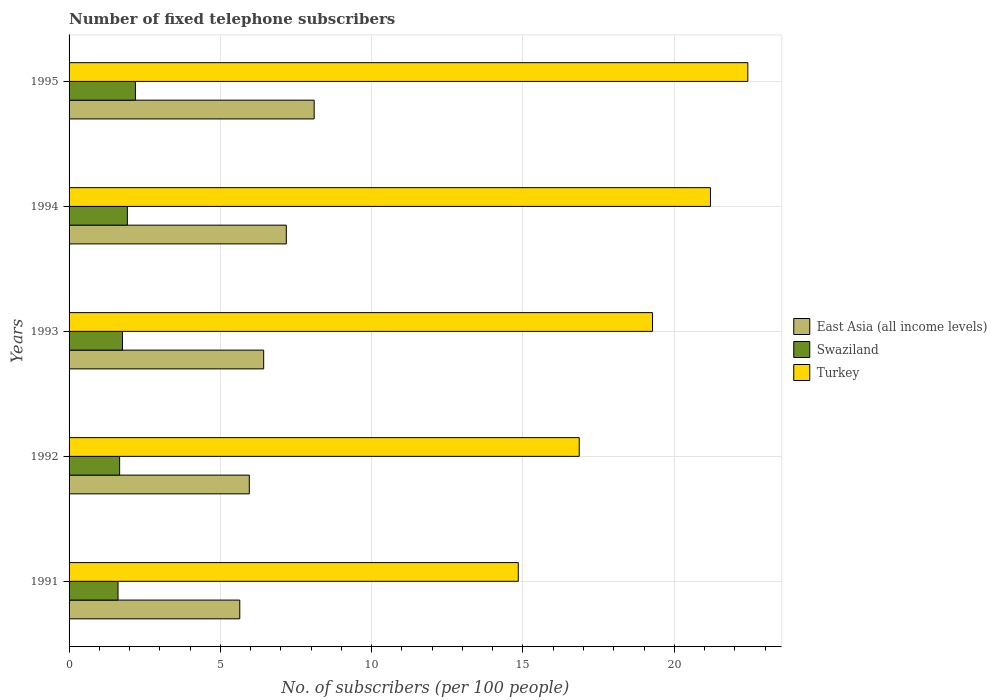What is the label of the 2nd group of bars from the top?
Provide a succinct answer. 1994. In how many cases, is the number of bars for a given year not equal to the number of legend labels?
Your answer should be very brief. 0. What is the number of fixed telephone subscribers in Turkey in 1991?
Your answer should be compact. 14.85. Across all years, what is the maximum number of fixed telephone subscribers in East Asia (all income levels)?
Offer a terse response. 8.1. Across all years, what is the minimum number of fixed telephone subscribers in East Asia (all income levels)?
Your response must be concise. 5.64. In which year was the number of fixed telephone subscribers in Swaziland minimum?
Give a very brief answer. 1991. What is the total number of fixed telephone subscribers in Swaziland in the graph?
Ensure brevity in your answer.  9.17. What is the difference between the number of fixed telephone subscribers in Swaziland in 1992 and that in 1995?
Provide a succinct answer. -0.52. What is the difference between the number of fixed telephone subscribers in East Asia (all income levels) in 1991 and the number of fixed telephone subscribers in Turkey in 1995?
Your answer should be very brief. -16.79. What is the average number of fixed telephone subscribers in Swaziland per year?
Your answer should be compact. 1.83. In the year 1995, what is the difference between the number of fixed telephone subscribers in Swaziland and number of fixed telephone subscribers in East Asia (all income levels)?
Keep it short and to the point. -5.91. In how many years, is the number of fixed telephone subscribers in Turkey greater than 15 ?
Ensure brevity in your answer.  4. What is the ratio of the number of fixed telephone subscribers in East Asia (all income levels) in 1991 to that in 1993?
Your response must be concise. 0.88. Is the number of fixed telephone subscribers in East Asia (all income levels) in 1992 less than that in 1993?
Your answer should be compact. Yes. Is the difference between the number of fixed telephone subscribers in Swaziland in 1992 and 1994 greater than the difference between the number of fixed telephone subscribers in East Asia (all income levels) in 1992 and 1994?
Keep it short and to the point. Yes. What is the difference between the highest and the second highest number of fixed telephone subscribers in Swaziland?
Your response must be concise. 0.27. What is the difference between the highest and the lowest number of fixed telephone subscribers in Swaziland?
Offer a terse response. 0.58. What does the 2nd bar from the top in 1993 represents?
Ensure brevity in your answer.  Swaziland. Are all the bars in the graph horizontal?
Ensure brevity in your answer.  Yes. How many years are there in the graph?
Offer a terse response. 5. What is the difference between two consecutive major ticks on the X-axis?
Ensure brevity in your answer.  5. Does the graph contain any zero values?
Your answer should be very brief. No. Does the graph contain grids?
Your response must be concise. Yes. Where does the legend appear in the graph?
Make the answer very short. Center right. How many legend labels are there?
Provide a short and direct response. 3. How are the legend labels stacked?
Make the answer very short. Vertical. What is the title of the graph?
Ensure brevity in your answer.  Number of fixed telephone subscribers. What is the label or title of the X-axis?
Keep it short and to the point. No. of subscribers (per 100 people). What is the No. of subscribers (per 100 people) in East Asia (all income levels) in 1991?
Make the answer very short. 5.64. What is the No. of subscribers (per 100 people) in Swaziland in 1991?
Your answer should be very brief. 1.62. What is the No. of subscribers (per 100 people) in Turkey in 1991?
Keep it short and to the point. 14.85. What is the No. of subscribers (per 100 people) of East Asia (all income levels) in 1992?
Offer a very short reply. 5.96. What is the No. of subscribers (per 100 people) in Swaziland in 1992?
Offer a terse response. 1.67. What is the No. of subscribers (per 100 people) of Turkey in 1992?
Your response must be concise. 16.86. What is the No. of subscribers (per 100 people) of East Asia (all income levels) in 1993?
Your answer should be compact. 6.43. What is the No. of subscribers (per 100 people) in Swaziland in 1993?
Offer a terse response. 1.76. What is the No. of subscribers (per 100 people) of Turkey in 1993?
Your response must be concise. 19.28. What is the No. of subscribers (per 100 people) in East Asia (all income levels) in 1994?
Your answer should be compact. 7.18. What is the No. of subscribers (per 100 people) of Swaziland in 1994?
Offer a very short reply. 1.93. What is the No. of subscribers (per 100 people) of Turkey in 1994?
Your response must be concise. 21.2. What is the No. of subscribers (per 100 people) of East Asia (all income levels) in 1995?
Offer a terse response. 8.1. What is the No. of subscribers (per 100 people) in Swaziland in 1995?
Your answer should be very brief. 2.19. What is the No. of subscribers (per 100 people) in Turkey in 1995?
Your answer should be compact. 22.43. Across all years, what is the maximum No. of subscribers (per 100 people) in East Asia (all income levels)?
Provide a short and direct response. 8.1. Across all years, what is the maximum No. of subscribers (per 100 people) in Swaziland?
Offer a very short reply. 2.19. Across all years, what is the maximum No. of subscribers (per 100 people) in Turkey?
Provide a short and direct response. 22.43. Across all years, what is the minimum No. of subscribers (per 100 people) of East Asia (all income levels)?
Offer a very short reply. 5.64. Across all years, what is the minimum No. of subscribers (per 100 people) in Swaziland?
Give a very brief answer. 1.62. Across all years, what is the minimum No. of subscribers (per 100 people) in Turkey?
Your response must be concise. 14.85. What is the total No. of subscribers (per 100 people) of East Asia (all income levels) in the graph?
Ensure brevity in your answer.  33.31. What is the total No. of subscribers (per 100 people) of Swaziland in the graph?
Provide a succinct answer. 9.17. What is the total No. of subscribers (per 100 people) in Turkey in the graph?
Offer a terse response. 94.61. What is the difference between the No. of subscribers (per 100 people) in East Asia (all income levels) in 1991 and that in 1992?
Your answer should be compact. -0.31. What is the difference between the No. of subscribers (per 100 people) of Swaziland in 1991 and that in 1992?
Provide a succinct answer. -0.05. What is the difference between the No. of subscribers (per 100 people) of Turkey in 1991 and that in 1992?
Your answer should be very brief. -2.01. What is the difference between the No. of subscribers (per 100 people) of East Asia (all income levels) in 1991 and that in 1993?
Ensure brevity in your answer.  -0.79. What is the difference between the No. of subscribers (per 100 people) in Swaziland in 1991 and that in 1993?
Keep it short and to the point. -0.15. What is the difference between the No. of subscribers (per 100 people) in Turkey in 1991 and that in 1993?
Your response must be concise. -4.44. What is the difference between the No. of subscribers (per 100 people) in East Asia (all income levels) in 1991 and that in 1994?
Your answer should be compact. -1.54. What is the difference between the No. of subscribers (per 100 people) in Swaziland in 1991 and that in 1994?
Ensure brevity in your answer.  -0.31. What is the difference between the No. of subscribers (per 100 people) in Turkey in 1991 and that in 1994?
Give a very brief answer. -6.35. What is the difference between the No. of subscribers (per 100 people) of East Asia (all income levels) in 1991 and that in 1995?
Offer a terse response. -2.46. What is the difference between the No. of subscribers (per 100 people) of Swaziland in 1991 and that in 1995?
Your answer should be compact. -0.58. What is the difference between the No. of subscribers (per 100 people) of Turkey in 1991 and that in 1995?
Offer a terse response. -7.59. What is the difference between the No. of subscribers (per 100 people) in East Asia (all income levels) in 1992 and that in 1993?
Keep it short and to the point. -0.47. What is the difference between the No. of subscribers (per 100 people) of Swaziland in 1992 and that in 1993?
Your response must be concise. -0.09. What is the difference between the No. of subscribers (per 100 people) in Turkey in 1992 and that in 1993?
Keep it short and to the point. -2.42. What is the difference between the No. of subscribers (per 100 people) in East Asia (all income levels) in 1992 and that in 1994?
Provide a succinct answer. -1.22. What is the difference between the No. of subscribers (per 100 people) in Swaziland in 1992 and that in 1994?
Offer a very short reply. -0.26. What is the difference between the No. of subscribers (per 100 people) in Turkey in 1992 and that in 1994?
Offer a terse response. -4.34. What is the difference between the No. of subscribers (per 100 people) of East Asia (all income levels) in 1992 and that in 1995?
Keep it short and to the point. -2.14. What is the difference between the No. of subscribers (per 100 people) of Swaziland in 1992 and that in 1995?
Give a very brief answer. -0.52. What is the difference between the No. of subscribers (per 100 people) in Turkey in 1992 and that in 1995?
Ensure brevity in your answer.  -5.57. What is the difference between the No. of subscribers (per 100 people) of East Asia (all income levels) in 1993 and that in 1994?
Ensure brevity in your answer.  -0.75. What is the difference between the No. of subscribers (per 100 people) of Swaziland in 1993 and that in 1994?
Keep it short and to the point. -0.16. What is the difference between the No. of subscribers (per 100 people) of Turkey in 1993 and that in 1994?
Provide a short and direct response. -1.91. What is the difference between the No. of subscribers (per 100 people) in East Asia (all income levels) in 1993 and that in 1995?
Provide a succinct answer. -1.67. What is the difference between the No. of subscribers (per 100 people) in Swaziland in 1993 and that in 1995?
Offer a very short reply. -0.43. What is the difference between the No. of subscribers (per 100 people) in Turkey in 1993 and that in 1995?
Keep it short and to the point. -3.15. What is the difference between the No. of subscribers (per 100 people) of East Asia (all income levels) in 1994 and that in 1995?
Offer a terse response. -0.92. What is the difference between the No. of subscribers (per 100 people) in Swaziland in 1994 and that in 1995?
Your answer should be compact. -0.27. What is the difference between the No. of subscribers (per 100 people) of Turkey in 1994 and that in 1995?
Your response must be concise. -1.23. What is the difference between the No. of subscribers (per 100 people) in East Asia (all income levels) in 1991 and the No. of subscribers (per 100 people) in Swaziland in 1992?
Give a very brief answer. 3.97. What is the difference between the No. of subscribers (per 100 people) in East Asia (all income levels) in 1991 and the No. of subscribers (per 100 people) in Turkey in 1992?
Provide a short and direct response. -11.22. What is the difference between the No. of subscribers (per 100 people) in Swaziland in 1991 and the No. of subscribers (per 100 people) in Turkey in 1992?
Your answer should be very brief. -15.24. What is the difference between the No. of subscribers (per 100 people) in East Asia (all income levels) in 1991 and the No. of subscribers (per 100 people) in Swaziland in 1993?
Ensure brevity in your answer.  3.88. What is the difference between the No. of subscribers (per 100 people) of East Asia (all income levels) in 1991 and the No. of subscribers (per 100 people) of Turkey in 1993?
Give a very brief answer. -13.64. What is the difference between the No. of subscribers (per 100 people) of Swaziland in 1991 and the No. of subscribers (per 100 people) of Turkey in 1993?
Offer a terse response. -17.66. What is the difference between the No. of subscribers (per 100 people) in East Asia (all income levels) in 1991 and the No. of subscribers (per 100 people) in Swaziland in 1994?
Give a very brief answer. 3.72. What is the difference between the No. of subscribers (per 100 people) of East Asia (all income levels) in 1991 and the No. of subscribers (per 100 people) of Turkey in 1994?
Ensure brevity in your answer.  -15.55. What is the difference between the No. of subscribers (per 100 people) of Swaziland in 1991 and the No. of subscribers (per 100 people) of Turkey in 1994?
Provide a succinct answer. -19.58. What is the difference between the No. of subscribers (per 100 people) of East Asia (all income levels) in 1991 and the No. of subscribers (per 100 people) of Swaziland in 1995?
Make the answer very short. 3.45. What is the difference between the No. of subscribers (per 100 people) of East Asia (all income levels) in 1991 and the No. of subscribers (per 100 people) of Turkey in 1995?
Your answer should be very brief. -16.79. What is the difference between the No. of subscribers (per 100 people) in Swaziland in 1991 and the No. of subscribers (per 100 people) in Turkey in 1995?
Provide a succinct answer. -20.81. What is the difference between the No. of subscribers (per 100 people) of East Asia (all income levels) in 1992 and the No. of subscribers (per 100 people) of Swaziland in 1993?
Provide a succinct answer. 4.19. What is the difference between the No. of subscribers (per 100 people) of East Asia (all income levels) in 1992 and the No. of subscribers (per 100 people) of Turkey in 1993?
Your response must be concise. -13.33. What is the difference between the No. of subscribers (per 100 people) of Swaziland in 1992 and the No. of subscribers (per 100 people) of Turkey in 1993?
Give a very brief answer. -17.61. What is the difference between the No. of subscribers (per 100 people) in East Asia (all income levels) in 1992 and the No. of subscribers (per 100 people) in Swaziland in 1994?
Provide a succinct answer. 4.03. What is the difference between the No. of subscribers (per 100 people) in East Asia (all income levels) in 1992 and the No. of subscribers (per 100 people) in Turkey in 1994?
Your response must be concise. -15.24. What is the difference between the No. of subscribers (per 100 people) of Swaziland in 1992 and the No. of subscribers (per 100 people) of Turkey in 1994?
Ensure brevity in your answer.  -19.53. What is the difference between the No. of subscribers (per 100 people) of East Asia (all income levels) in 1992 and the No. of subscribers (per 100 people) of Swaziland in 1995?
Provide a short and direct response. 3.76. What is the difference between the No. of subscribers (per 100 people) of East Asia (all income levels) in 1992 and the No. of subscribers (per 100 people) of Turkey in 1995?
Offer a terse response. -16.47. What is the difference between the No. of subscribers (per 100 people) in Swaziland in 1992 and the No. of subscribers (per 100 people) in Turkey in 1995?
Keep it short and to the point. -20.76. What is the difference between the No. of subscribers (per 100 people) of East Asia (all income levels) in 1993 and the No. of subscribers (per 100 people) of Swaziland in 1994?
Give a very brief answer. 4.5. What is the difference between the No. of subscribers (per 100 people) of East Asia (all income levels) in 1993 and the No. of subscribers (per 100 people) of Turkey in 1994?
Provide a succinct answer. -14.77. What is the difference between the No. of subscribers (per 100 people) in Swaziland in 1993 and the No. of subscribers (per 100 people) in Turkey in 1994?
Offer a very short reply. -19.43. What is the difference between the No. of subscribers (per 100 people) in East Asia (all income levels) in 1993 and the No. of subscribers (per 100 people) in Swaziland in 1995?
Give a very brief answer. 4.24. What is the difference between the No. of subscribers (per 100 people) of East Asia (all income levels) in 1993 and the No. of subscribers (per 100 people) of Turkey in 1995?
Your response must be concise. -16. What is the difference between the No. of subscribers (per 100 people) of Swaziland in 1993 and the No. of subscribers (per 100 people) of Turkey in 1995?
Provide a short and direct response. -20.67. What is the difference between the No. of subscribers (per 100 people) of East Asia (all income levels) in 1994 and the No. of subscribers (per 100 people) of Swaziland in 1995?
Ensure brevity in your answer.  4.99. What is the difference between the No. of subscribers (per 100 people) of East Asia (all income levels) in 1994 and the No. of subscribers (per 100 people) of Turkey in 1995?
Provide a succinct answer. -15.25. What is the difference between the No. of subscribers (per 100 people) in Swaziland in 1994 and the No. of subscribers (per 100 people) in Turkey in 1995?
Ensure brevity in your answer.  -20.5. What is the average No. of subscribers (per 100 people) in East Asia (all income levels) per year?
Keep it short and to the point. 6.66. What is the average No. of subscribers (per 100 people) of Swaziland per year?
Give a very brief answer. 1.83. What is the average No. of subscribers (per 100 people) in Turkey per year?
Your response must be concise. 18.92. In the year 1991, what is the difference between the No. of subscribers (per 100 people) of East Asia (all income levels) and No. of subscribers (per 100 people) of Swaziland?
Provide a succinct answer. 4.02. In the year 1991, what is the difference between the No. of subscribers (per 100 people) of East Asia (all income levels) and No. of subscribers (per 100 people) of Turkey?
Provide a succinct answer. -9.2. In the year 1991, what is the difference between the No. of subscribers (per 100 people) of Swaziland and No. of subscribers (per 100 people) of Turkey?
Provide a succinct answer. -13.23. In the year 1992, what is the difference between the No. of subscribers (per 100 people) of East Asia (all income levels) and No. of subscribers (per 100 people) of Swaziland?
Give a very brief answer. 4.29. In the year 1992, what is the difference between the No. of subscribers (per 100 people) in East Asia (all income levels) and No. of subscribers (per 100 people) in Turkey?
Offer a terse response. -10.9. In the year 1992, what is the difference between the No. of subscribers (per 100 people) of Swaziland and No. of subscribers (per 100 people) of Turkey?
Ensure brevity in your answer.  -15.19. In the year 1993, what is the difference between the No. of subscribers (per 100 people) in East Asia (all income levels) and No. of subscribers (per 100 people) in Swaziland?
Keep it short and to the point. 4.67. In the year 1993, what is the difference between the No. of subscribers (per 100 people) of East Asia (all income levels) and No. of subscribers (per 100 people) of Turkey?
Provide a succinct answer. -12.85. In the year 1993, what is the difference between the No. of subscribers (per 100 people) of Swaziland and No. of subscribers (per 100 people) of Turkey?
Keep it short and to the point. -17.52. In the year 1994, what is the difference between the No. of subscribers (per 100 people) of East Asia (all income levels) and No. of subscribers (per 100 people) of Swaziland?
Make the answer very short. 5.25. In the year 1994, what is the difference between the No. of subscribers (per 100 people) in East Asia (all income levels) and No. of subscribers (per 100 people) in Turkey?
Your response must be concise. -14.02. In the year 1994, what is the difference between the No. of subscribers (per 100 people) of Swaziland and No. of subscribers (per 100 people) of Turkey?
Your answer should be compact. -19.27. In the year 1995, what is the difference between the No. of subscribers (per 100 people) in East Asia (all income levels) and No. of subscribers (per 100 people) in Swaziland?
Give a very brief answer. 5.91. In the year 1995, what is the difference between the No. of subscribers (per 100 people) in East Asia (all income levels) and No. of subscribers (per 100 people) in Turkey?
Provide a succinct answer. -14.33. In the year 1995, what is the difference between the No. of subscribers (per 100 people) in Swaziland and No. of subscribers (per 100 people) in Turkey?
Your response must be concise. -20.24. What is the ratio of the No. of subscribers (per 100 people) in East Asia (all income levels) in 1991 to that in 1992?
Give a very brief answer. 0.95. What is the ratio of the No. of subscribers (per 100 people) in Swaziland in 1991 to that in 1992?
Ensure brevity in your answer.  0.97. What is the ratio of the No. of subscribers (per 100 people) in Turkey in 1991 to that in 1992?
Ensure brevity in your answer.  0.88. What is the ratio of the No. of subscribers (per 100 people) of East Asia (all income levels) in 1991 to that in 1993?
Give a very brief answer. 0.88. What is the ratio of the No. of subscribers (per 100 people) of Swaziland in 1991 to that in 1993?
Your answer should be very brief. 0.92. What is the ratio of the No. of subscribers (per 100 people) of Turkey in 1991 to that in 1993?
Your answer should be very brief. 0.77. What is the ratio of the No. of subscribers (per 100 people) in East Asia (all income levels) in 1991 to that in 1994?
Your answer should be compact. 0.79. What is the ratio of the No. of subscribers (per 100 people) of Swaziland in 1991 to that in 1994?
Keep it short and to the point. 0.84. What is the ratio of the No. of subscribers (per 100 people) in Turkey in 1991 to that in 1994?
Provide a succinct answer. 0.7. What is the ratio of the No. of subscribers (per 100 people) of East Asia (all income levels) in 1991 to that in 1995?
Offer a terse response. 0.7. What is the ratio of the No. of subscribers (per 100 people) of Swaziland in 1991 to that in 1995?
Offer a very short reply. 0.74. What is the ratio of the No. of subscribers (per 100 people) in Turkey in 1991 to that in 1995?
Offer a terse response. 0.66. What is the ratio of the No. of subscribers (per 100 people) in East Asia (all income levels) in 1992 to that in 1993?
Offer a terse response. 0.93. What is the ratio of the No. of subscribers (per 100 people) of Swaziland in 1992 to that in 1993?
Your response must be concise. 0.95. What is the ratio of the No. of subscribers (per 100 people) of Turkey in 1992 to that in 1993?
Offer a very short reply. 0.87. What is the ratio of the No. of subscribers (per 100 people) in East Asia (all income levels) in 1992 to that in 1994?
Your answer should be compact. 0.83. What is the ratio of the No. of subscribers (per 100 people) in Swaziland in 1992 to that in 1994?
Ensure brevity in your answer.  0.87. What is the ratio of the No. of subscribers (per 100 people) of Turkey in 1992 to that in 1994?
Your answer should be very brief. 0.8. What is the ratio of the No. of subscribers (per 100 people) in East Asia (all income levels) in 1992 to that in 1995?
Offer a terse response. 0.74. What is the ratio of the No. of subscribers (per 100 people) in Swaziland in 1992 to that in 1995?
Your answer should be very brief. 0.76. What is the ratio of the No. of subscribers (per 100 people) in Turkey in 1992 to that in 1995?
Your response must be concise. 0.75. What is the ratio of the No. of subscribers (per 100 people) in East Asia (all income levels) in 1993 to that in 1994?
Your answer should be very brief. 0.9. What is the ratio of the No. of subscribers (per 100 people) of Swaziland in 1993 to that in 1994?
Make the answer very short. 0.92. What is the ratio of the No. of subscribers (per 100 people) of Turkey in 1993 to that in 1994?
Your response must be concise. 0.91. What is the ratio of the No. of subscribers (per 100 people) of East Asia (all income levels) in 1993 to that in 1995?
Your answer should be very brief. 0.79. What is the ratio of the No. of subscribers (per 100 people) in Swaziland in 1993 to that in 1995?
Ensure brevity in your answer.  0.8. What is the ratio of the No. of subscribers (per 100 people) of Turkey in 1993 to that in 1995?
Offer a very short reply. 0.86. What is the ratio of the No. of subscribers (per 100 people) in East Asia (all income levels) in 1994 to that in 1995?
Your response must be concise. 0.89. What is the ratio of the No. of subscribers (per 100 people) of Swaziland in 1994 to that in 1995?
Offer a very short reply. 0.88. What is the ratio of the No. of subscribers (per 100 people) of Turkey in 1994 to that in 1995?
Provide a succinct answer. 0.94. What is the difference between the highest and the second highest No. of subscribers (per 100 people) in East Asia (all income levels)?
Make the answer very short. 0.92. What is the difference between the highest and the second highest No. of subscribers (per 100 people) of Swaziland?
Ensure brevity in your answer.  0.27. What is the difference between the highest and the second highest No. of subscribers (per 100 people) in Turkey?
Your answer should be very brief. 1.23. What is the difference between the highest and the lowest No. of subscribers (per 100 people) in East Asia (all income levels)?
Keep it short and to the point. 2.46. What is the difference between the highest and the lowest No. of subscribers (per 100 people) of Swaziland?
Make the answer very short. 0.58. What is the difference between the highest and the lowest No. of subscribers (per 100 people) of Turkey?
Offer a terse response. 7.59. 